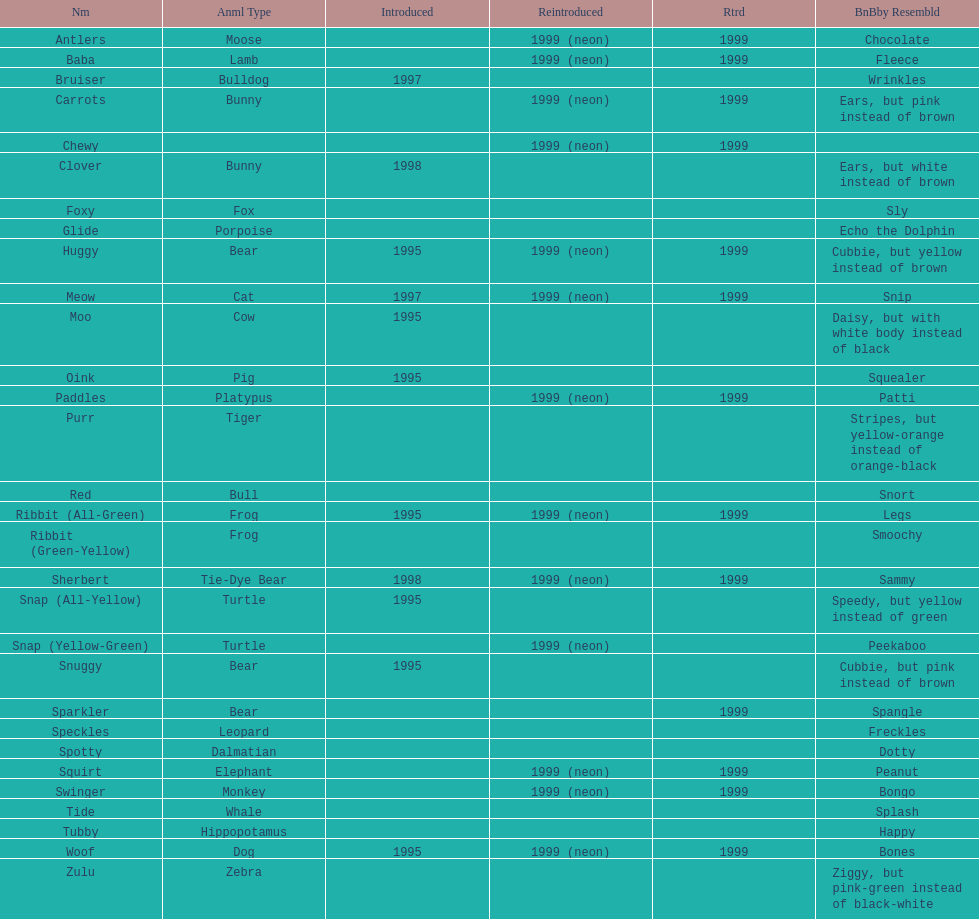What is the name of the pillow pal listed after clover? Foxy. 